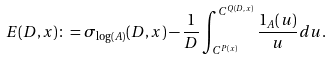<formula> <loc_0><loc_0><loc_500><loc_500>E ( D , x ) \colon = \sigma _ { \log ( A ) } ( D , x ) - \frac { 1 } { D } \int _ { C ^ { P ( x ) } } ^ { C ^ { Q ( D , x ) } } \frac { 1 _ { A } ( u ) } { u } d u .</formula> 